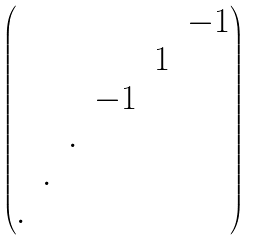Convert formula to latex. <formula><loc_0><loc_0><loc_500><loc_500>\begin{pmatrix} & & & & & - 1 \\ & & & & 1 \\ & & & - 1 \\ & & . \\ & . \\ . \end{pmatrix}</formula> 